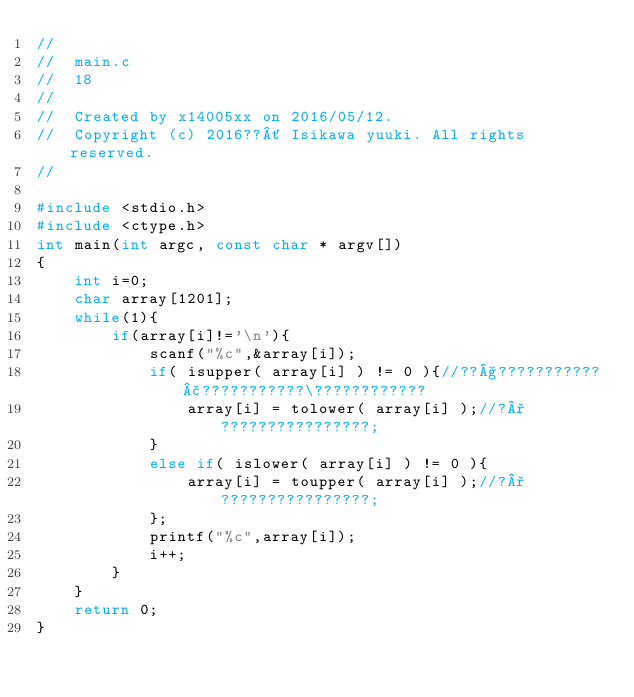<code> <loc_0><loc_0><loc_500><loc_500><_C_>//
//  main.c
//  18
//
//  Created by x14005xx on 2016/05/12.
//  Copyright (c) 2016??´ Isikawa yuuki. All rights reserved.
//

#include <stdio.h>
#include <ctype.h>
int main(int argc, const char * argv[])
{
    int i=0;
    char array[1201];
    while(1){
        if(array[i]!='\n'){
            scanf("%c",&array[i]);
            if( isupper( array[i] ) != 0 ){//??§???????????£???????????\????????????
                array[i] = tolower( array[i] );//?°????????????????;
            }
            else if( islower( array[i] ) != 0 ){
                array[i] = toupper( array[i] );//?°????????????????;
            };
            printf("%c",array[i]);
            i++;
        }
    }
    return 0;
}</code> 